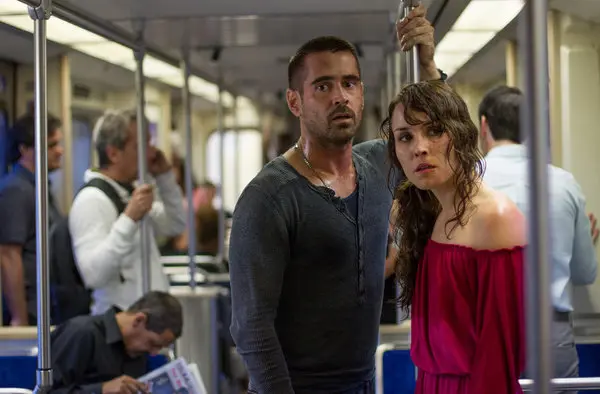Let's get creative! Suppose the subway setting is actually a spaceship. Describe the new context and story. In this imaginative scenario, the subway car transforms into the interior of a spaceship hurtling through space. Noomi Rapace, now dressed in a sleek, futuristic red space suit, and Colin Farrell, in a gray high-tech uniform, are on a mission to save their colony. They stand amid advanced control panels and holographic displays showing cosmic vistas and alerts. The blurred passengers are now fellow crew members, some checking instruments, others working on critical tasks. The sharegpt4v/same expressions of concern remain, but now they are facing the imminent threat of an asteroid field or a malfunction that could jeopardize their mission. The confined space of the spaceship, paired with the high-stakes scenario, exponentially heightens the tension and urgency of their situation. Based on the new context, create a thrilling plot twist involving the characters revealed in the middle of their space mission. As Noomi Rapace and Colin Farrell's characters navigate the spaceship's perilous journey, a sudden plot twist occurs. They discover that one of the crew members has been sabotaging the mission. Amid the chaos of avoiding the asteroid field, a series of unexplained malfunctions lead them to suspect an insider's betrayal. Tension mounts as they narrow down the suspects, each crew member's loyalty coming into question. The climax reveals a shocking truth: the saboteur is a trusted ally who has been blackmailed by a rival faction from a nearby colony, threatening his family's safety. Faced with this twist, Noomi and Colin's characters must make split-second decisions to thwart the saboteur, save the mission, and find a way to protect the crew member's family. This unexpected discovery adds layers of complexity and moral dilemma, elevating the narrative to a riveting space thriller. 